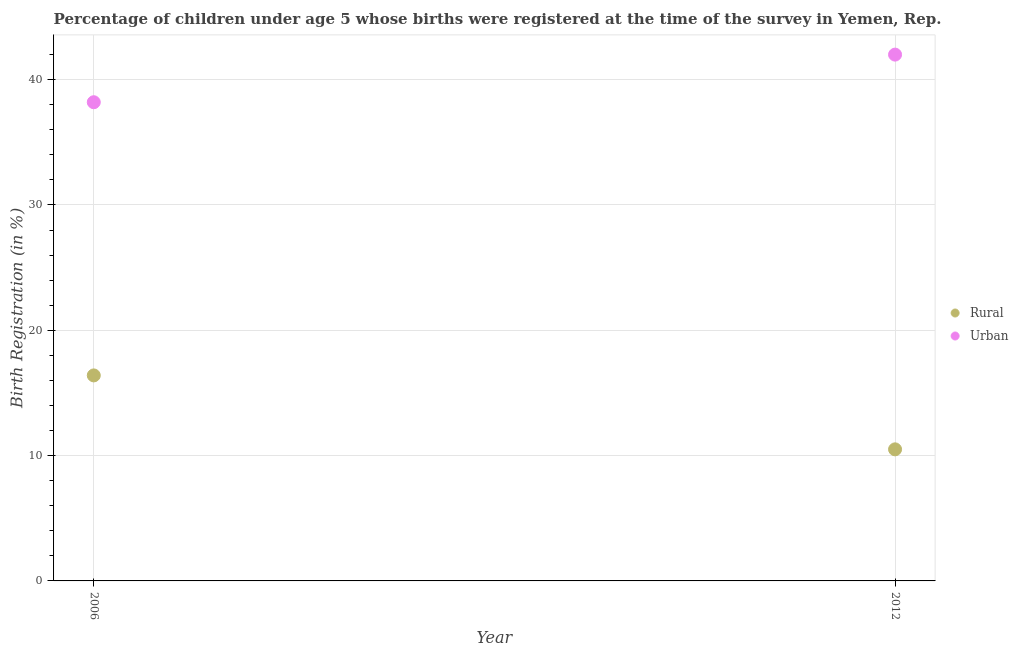What is the urban birth registration in 2006?
Offer a very short reply. 38.2. Across all years, what is the maximum urban birth registration?
Provide a short and direct response. 42. Across all years, what is the minimum urban birth registration?
Provide a short and direct response. 38.2. In which year was the urban birth registration maximum?
Ensure brevity in your answer.  2012. In which year was the urban birth registration minimum?
Provide a short and direct response. 2006. What is the total rural birth registration in the graph?
Keep it short and to the point. 26.9. What is the difference between the urban birth registration in 2006 and that in 2012?
Provide a succinct answer. -3.8. What is the difference between the rural birth registration in 2006 and the urban birth registration in 2012?
Your answer should be very brief. -25.6. What is the average rural birth registration per year?
Your response must be concise. 13.45. In the year 2006, what is the difference between the rural birth registration and urban birth registration?
Ensure brevity in your answer.  -21.8. In how many years, is the rural birth registration greater than 24 %?
Keep it short and to the point. 0. What is the ratio of the urban birth registration in 2006 to that in 2012?
Your answer should be compact. 0.91. Is the urban birth registration strictly greater than the rural birth registration over the years?
Your response must be concise. Yes. How many dotlines are there?
Keep it short and to the point. 2. What is the difference between two consecutive major ticks on the Y-axis?
Offer a terse response. 10. Where does the legend appear in the graph?
Make the answer very short. Center right. How are the legend labels stacked?
Keep it short and to the point. Vertical. What is the title of the graph?
Your response must be concise. Percentage of children under age 5 whose births were registered at the time of the survey in Yemen, Rep. What is the label or title of the Y-axis?
Your answer should be very brief. Birth Registration (in %). What is the Birth Registration (in %) in Urban in 2006?
Provide a succinct answer. 38.2. What is the Birth Registration (in %) in Rural in 2012?
Your answer should be very brief. 10.5. What is the Birth Registration (in %) of Urban in 2012?
Ensure brevity in your answer.  42. Across all years, what is the maximum Birth Registration (in %) in Rural?
Your answer should be compact. 16.4. Across all years, what is the maximum Birth Registration (in %) of Urban?
Ensure brevity in your answer.  42. Across all years, what is the minimum Birth Registration (in %) of Urban?
Offer a terse response. 38.2. What is the total Birth Registration (in %) of Rural in the graph?
Your answer should be compact. 26.9. What is the total Birth Registration (in %) in Urban in the graph?
Your response must be concise. 80.2. What is the difference between the Birth Registration (in %) of Urban in 2006 and that in 2012?
Offer a terse response. -3.8. What is the difference between the Birth Registration (in %) of Rural in 2006 and the Birth Registration (in %) of Urban in 2012?
Keep it short and to the point. -25.6. What is the average Birth Registration (in %) in Rural per year?
Give a very brief answer. 13.45. What is the average Birth Registration (in %) of Urban per year?
Offer a terse response. 40.1. In the year 2006, what is the difference between the Birth Registration (in %) of Rural and Birth Registration (in %) of Urban?
Your answer should be very brief. -21.8. In the year 2012, what is the difference between the Birth Registration (in %) in Rural and Birth Registration (in %) in Urban?
Provide a short and direct response. -31.5. What is the ratio of the Birth Registration (in %) of Rural in 2006 to that in 2012?
Provide a short and direct response. 1.56. What is the ratio of the Birth Registration (in %) in Urban in 2006 to that in 2012?
Your response must be concise. 0.91. What is the difference between the highest and the second highest Birth Registration (in %) in Rural?
Keep it short and to the point. 5.9. What is the difference between the highest and the second highest Birth Registration (in %) of Urban?
Offer a very short reply. 3.8. 